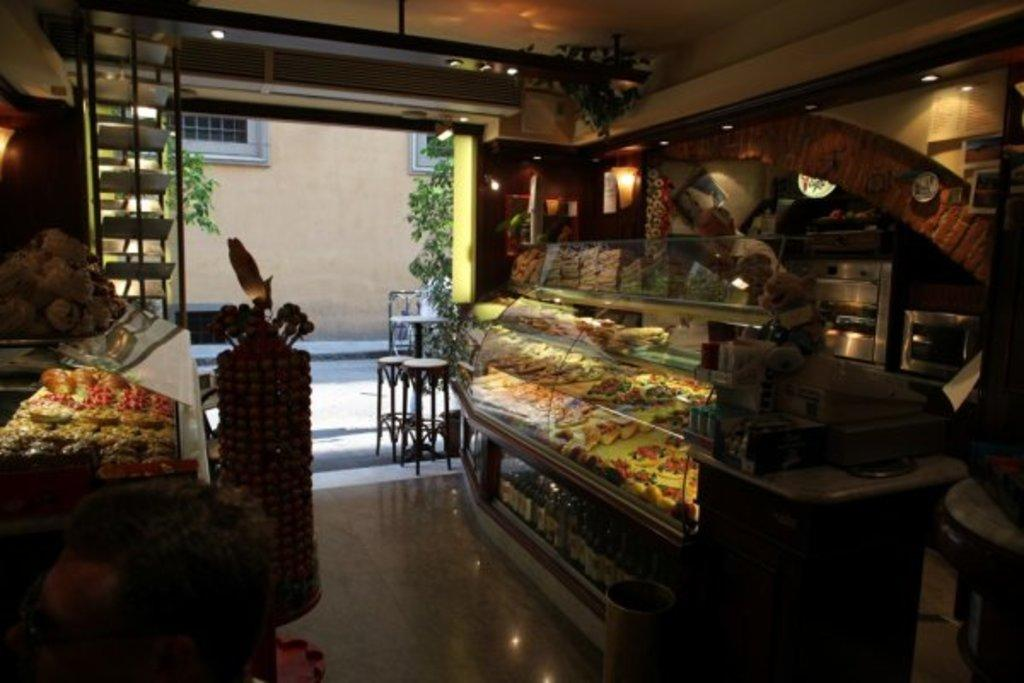What type of establishment is depicted in the image? There is a store in the image. How are the cakes displayed in the store? The cakes are placed in stands in the store. Where is the confectionery located in the store? The confectionery is placed in shelves in the store. Can you describe the presence of a person in the image? There is a man standing in the store. What type of class is being held at the seashore in the image? There is no class or seashore present in the image; it features a store with cakes and confectionery. What is the aftermath of the event that took place in the store? There is no event or aftermath mentioned in the image; it simply shows a store with a man standing inside. 